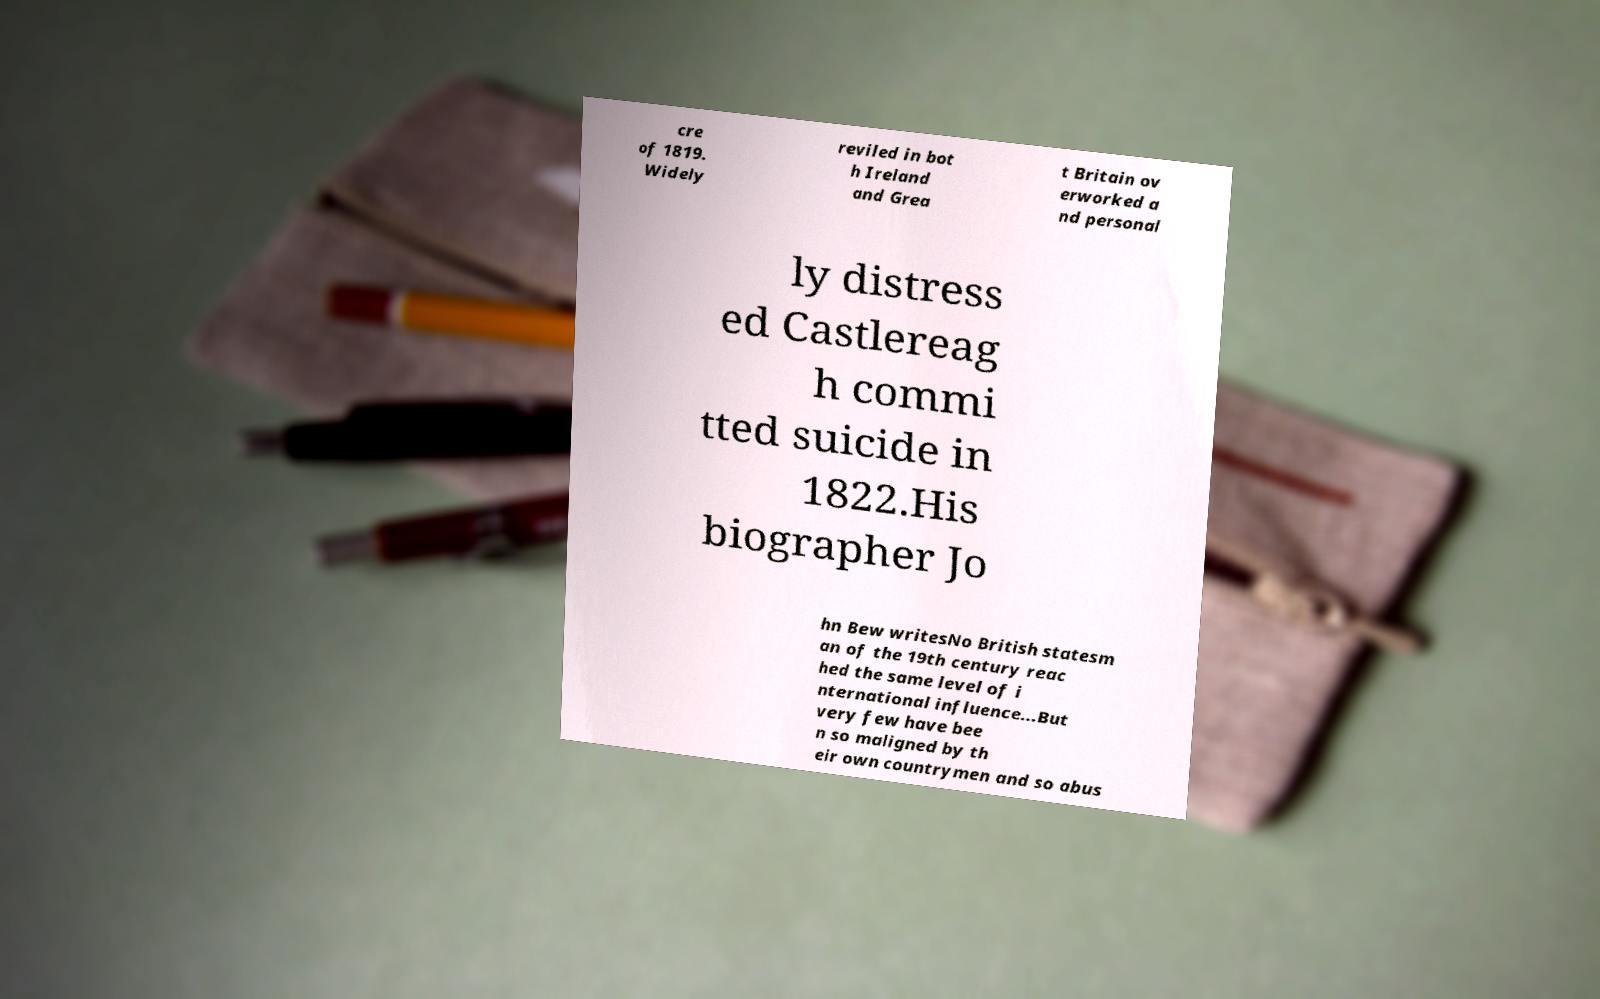Could you assist in decoding the text presented in this image and type it out clearly? cre of 1819. Widely reviled in bot h Ireland and Grea t Britain ov erworked a nd personal ly distress ed Castlereag h commi tted suicide in 1822.His biographer Jo hn Bew writesNo British statesm an of the 19th century reac hed the same level of i nternational influence...But very few have bee n so maligned by th eir own countrymen and so abus 